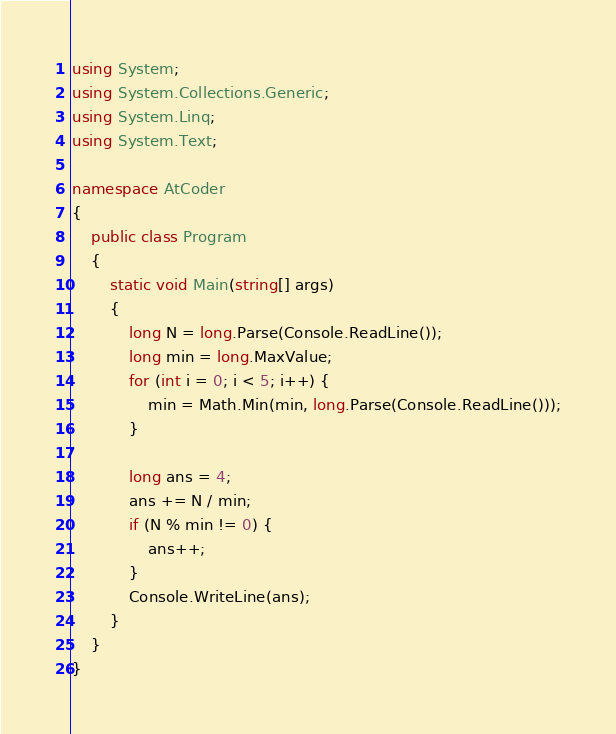<code> <loc_0><loc_0><loc_500><loc_500><_C#_>using System;
using System.Collections.Generic;
using System.Linq;
using System.Text;

namespace AtCoder
{
	public class Program
	{
		static void Main(string[] args)
		{
			long N = long.Parse(Console.ReadLine());
			long min = long.MaxValue;
			for (int i = 0; i < 5; i++) {
				min = Math.Min(min, long.Parse(Console.ReadLine()));
			}

			long ans = 4;
			ans += N / min;
			if (N % min != 0) {
				ans++;
			}
			Console.WriteLine(ans);
		}
	}
}</code> 